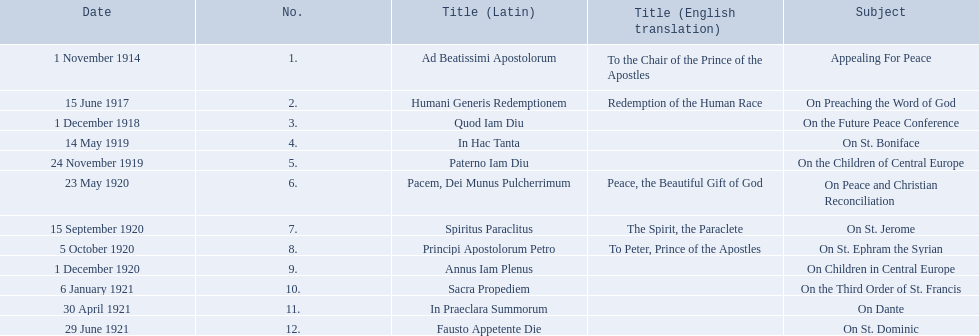What is the dates of the list of encyclicals of pope benedict xv? 1 November 1914, 15 June 1917, 1 December 1918, 14 May 1919, 24 November 1919, 23 May 1920, 15 September 1920, 5 October 1920, 1 December 1920, 6 January 1921, 30 April 1921, 29 June 1921. Of these dates, which subject was on 23 may 1920? On Peace and Christian Reconciliation. 